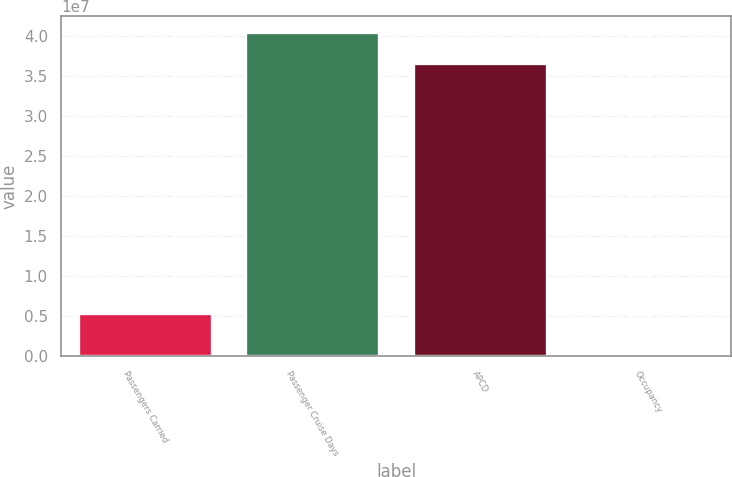Convert chart to OTSL. <chart><loc_0><loc_0><loc_500><loc_500><bar_chart><fcel>Passengers Carried<fcel>Passenger Cruise Days<fcel>APCD<fcel>Occupancy<nl><fcel>5.4019e+06<fcel>4.04989e+07<fcel>3.66466e+07<fcel>105.1<nl></chart> 